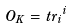Convert formula to latex. <formula><loc_0><loc_0><loc_500><loc_500>O _ { K } = t r \overline { \Phi } _ { i } \Phi ^ { i }</formula> 